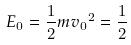Convert formula to latex. <formula><loc_0><loc_0><loc_500><loc_500>E _ { 0 } = \frac { 1 } { 2 } m { v _ { 0 } } ^ { 2 } = \frac { 1 } { 2 }</formula> 